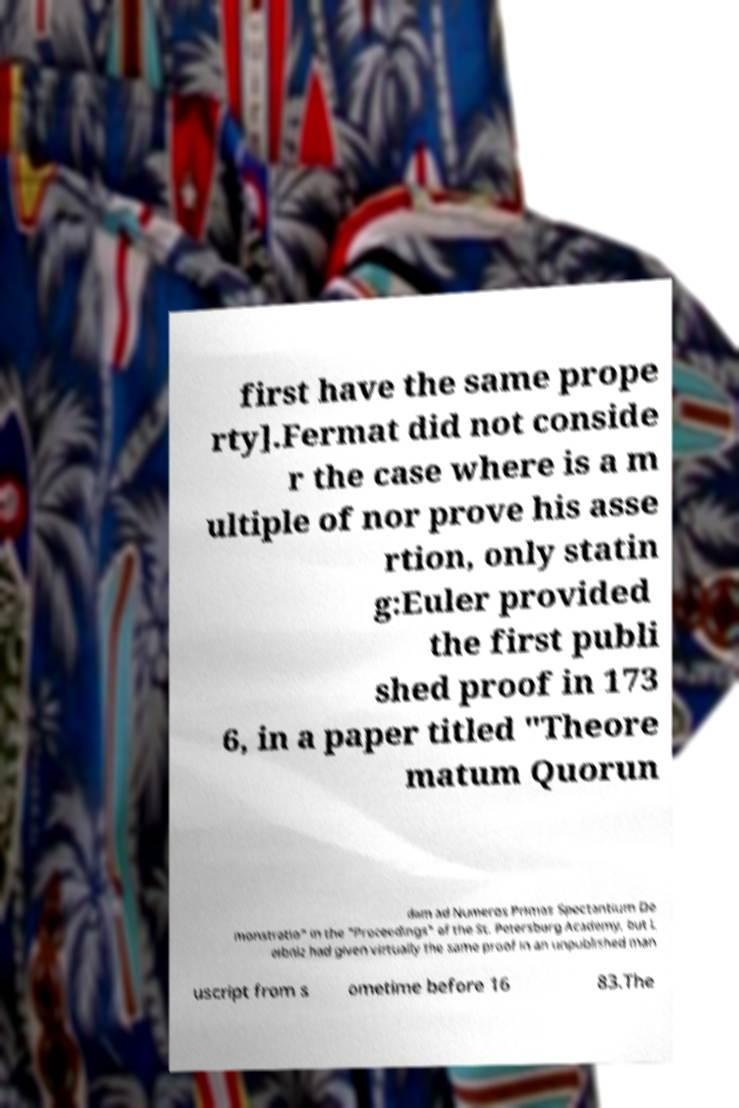Could you assist in decoding the text presented in this image and type it out clearly? first have the same prope rty].Fermat did not conside r the case where is a m ultiple of nor prove his asse rtion, only statin g:Euler provided the first publi shed proof in 173 6, in a paper titled "Theore matum Quorun dam ad Numeros Primos Spectantium De monstratio" in the "Proceedings" of the St. Petersburg Academy, but L eibniz had given virtually the same proof in an unpublished man uscript from s ometime before 16 83.The 